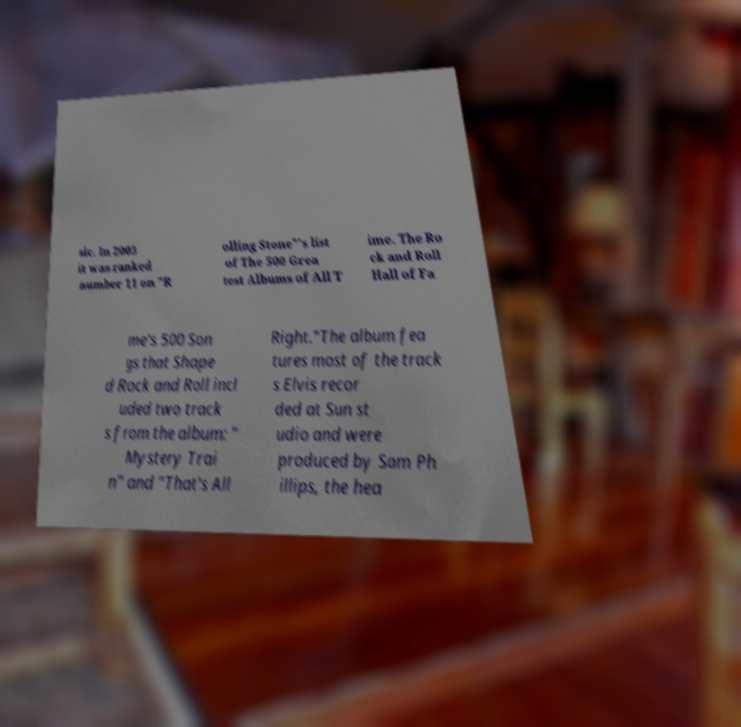For documentation purposes, I need the text within this image transcribed. Could you provide that? sic. In 2003 it was ranked number 11 on "R olling Stone"'s list of The 500 Grea test Albums of All T ime. The Ro ck and Roll Hall of Fa me's 500 Son gs that Shape d Rock and Roll incl uded two track s from the album: " Mystery Trai n" and "That's All Right."The album fea tures most of the track s Elvis recor ded at Sun st udio and were produced by Sam Ph illips, the hea 